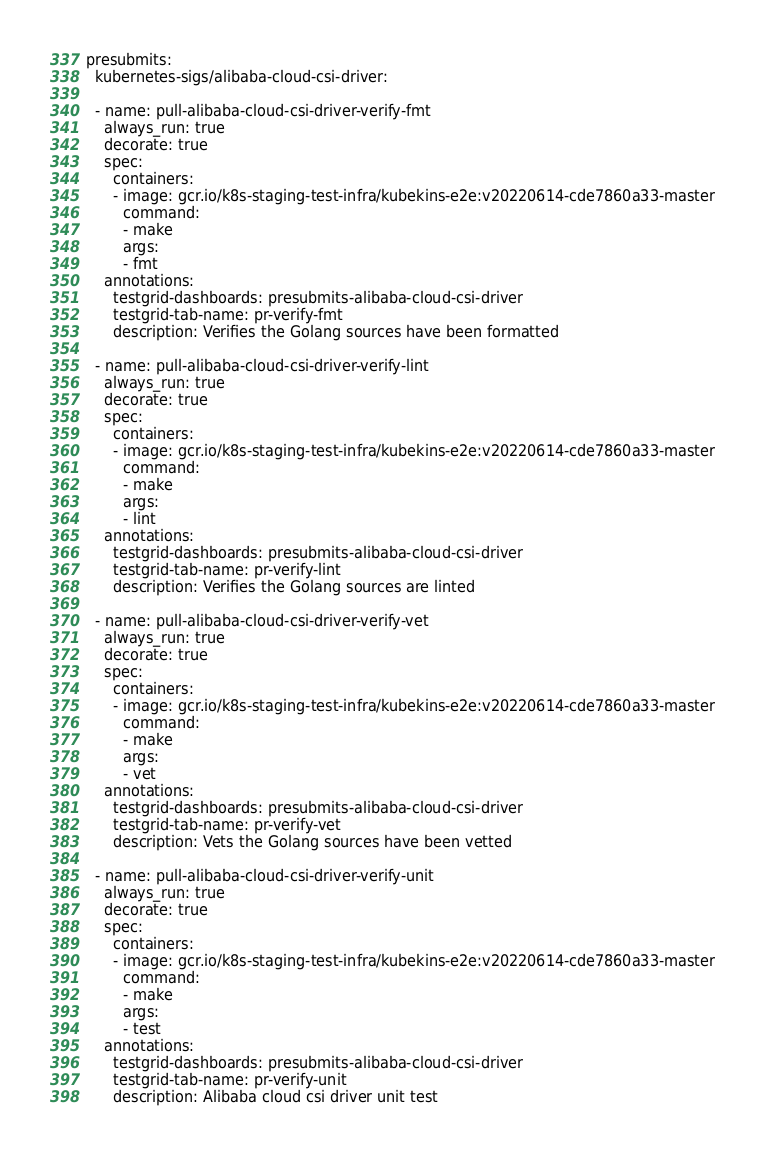Convert code to text. <code><loc_0><loc_0><loc_500><loc_500><_YAML_>presubmits:
  kubernetes-sigs/alibaba-cloud-csi-driver:

  - name: pull-alibaba-cloud-csi-driver-verify-fmt
    always_run: true
    decorate: true
    spec:
      containers:
      - image: gcr.io/k8s-staging-test-infra/kubekins-e2e:v20220614-cde7860a33-master
        command:
        - make
        args:
        - fmt
    annotations:
      testgrid-dashboards: presubmits-alibaba-cloud-csi-driver
      testgrid-tab-name: pr-verify-fmt
      description: Verifies the Golang sources have been formatted

  - name: pull-alibaba-cloud-csi-driver-verify-lint
    always_run: true
    decorate: true
    spec:
      containers:
      - image: gcr.io/k8s-staging-test-infra/kubekins-e2e:v20220614-cde7860a33-master
        command:
        - make
        args:
        - lint
    annotations:
      testgrid-dashboards: presubmits-alibaba-cloud-csi-driver
      testgrid-tab-name: pr-verify-lint
      description: Verifies the Golang sources are linted

  - name: pull-alibaba-cloud-csi-driver-verify-vet
    always_run: true
    decorate: true
    spec:
      containers:
      - image: gcr.io/k8s-staging-test-infra/kubekins-e2e:v20220614-cde7860a33-master
        command:
        - make
        args:
        - vet
    annotations:
      testgrid-dashboards: presubmits-alibaba-cloud-csi-driver
      testgrid-tab-name: pr-verify-vet
      description: Vets the Golang sources have been vetted

  - name: pull-alibaba-cloud-csi-driver-verify-unit
    always_run: true
    decorate: true
    spec:
      containers:
      - image: gcr.io/k8s-staging-test-infra/kubekins-e2e:v20220614-cde7860a33-master
        command:
        - make
        args:
        - test
    annotations:
      testgrid-dashboards: presubmits-alibaba-cloud-csi-driver
      testgrid-tab-name: pr-verify-unit
      description: Alibaba cloud csi driver unit test
</code> 